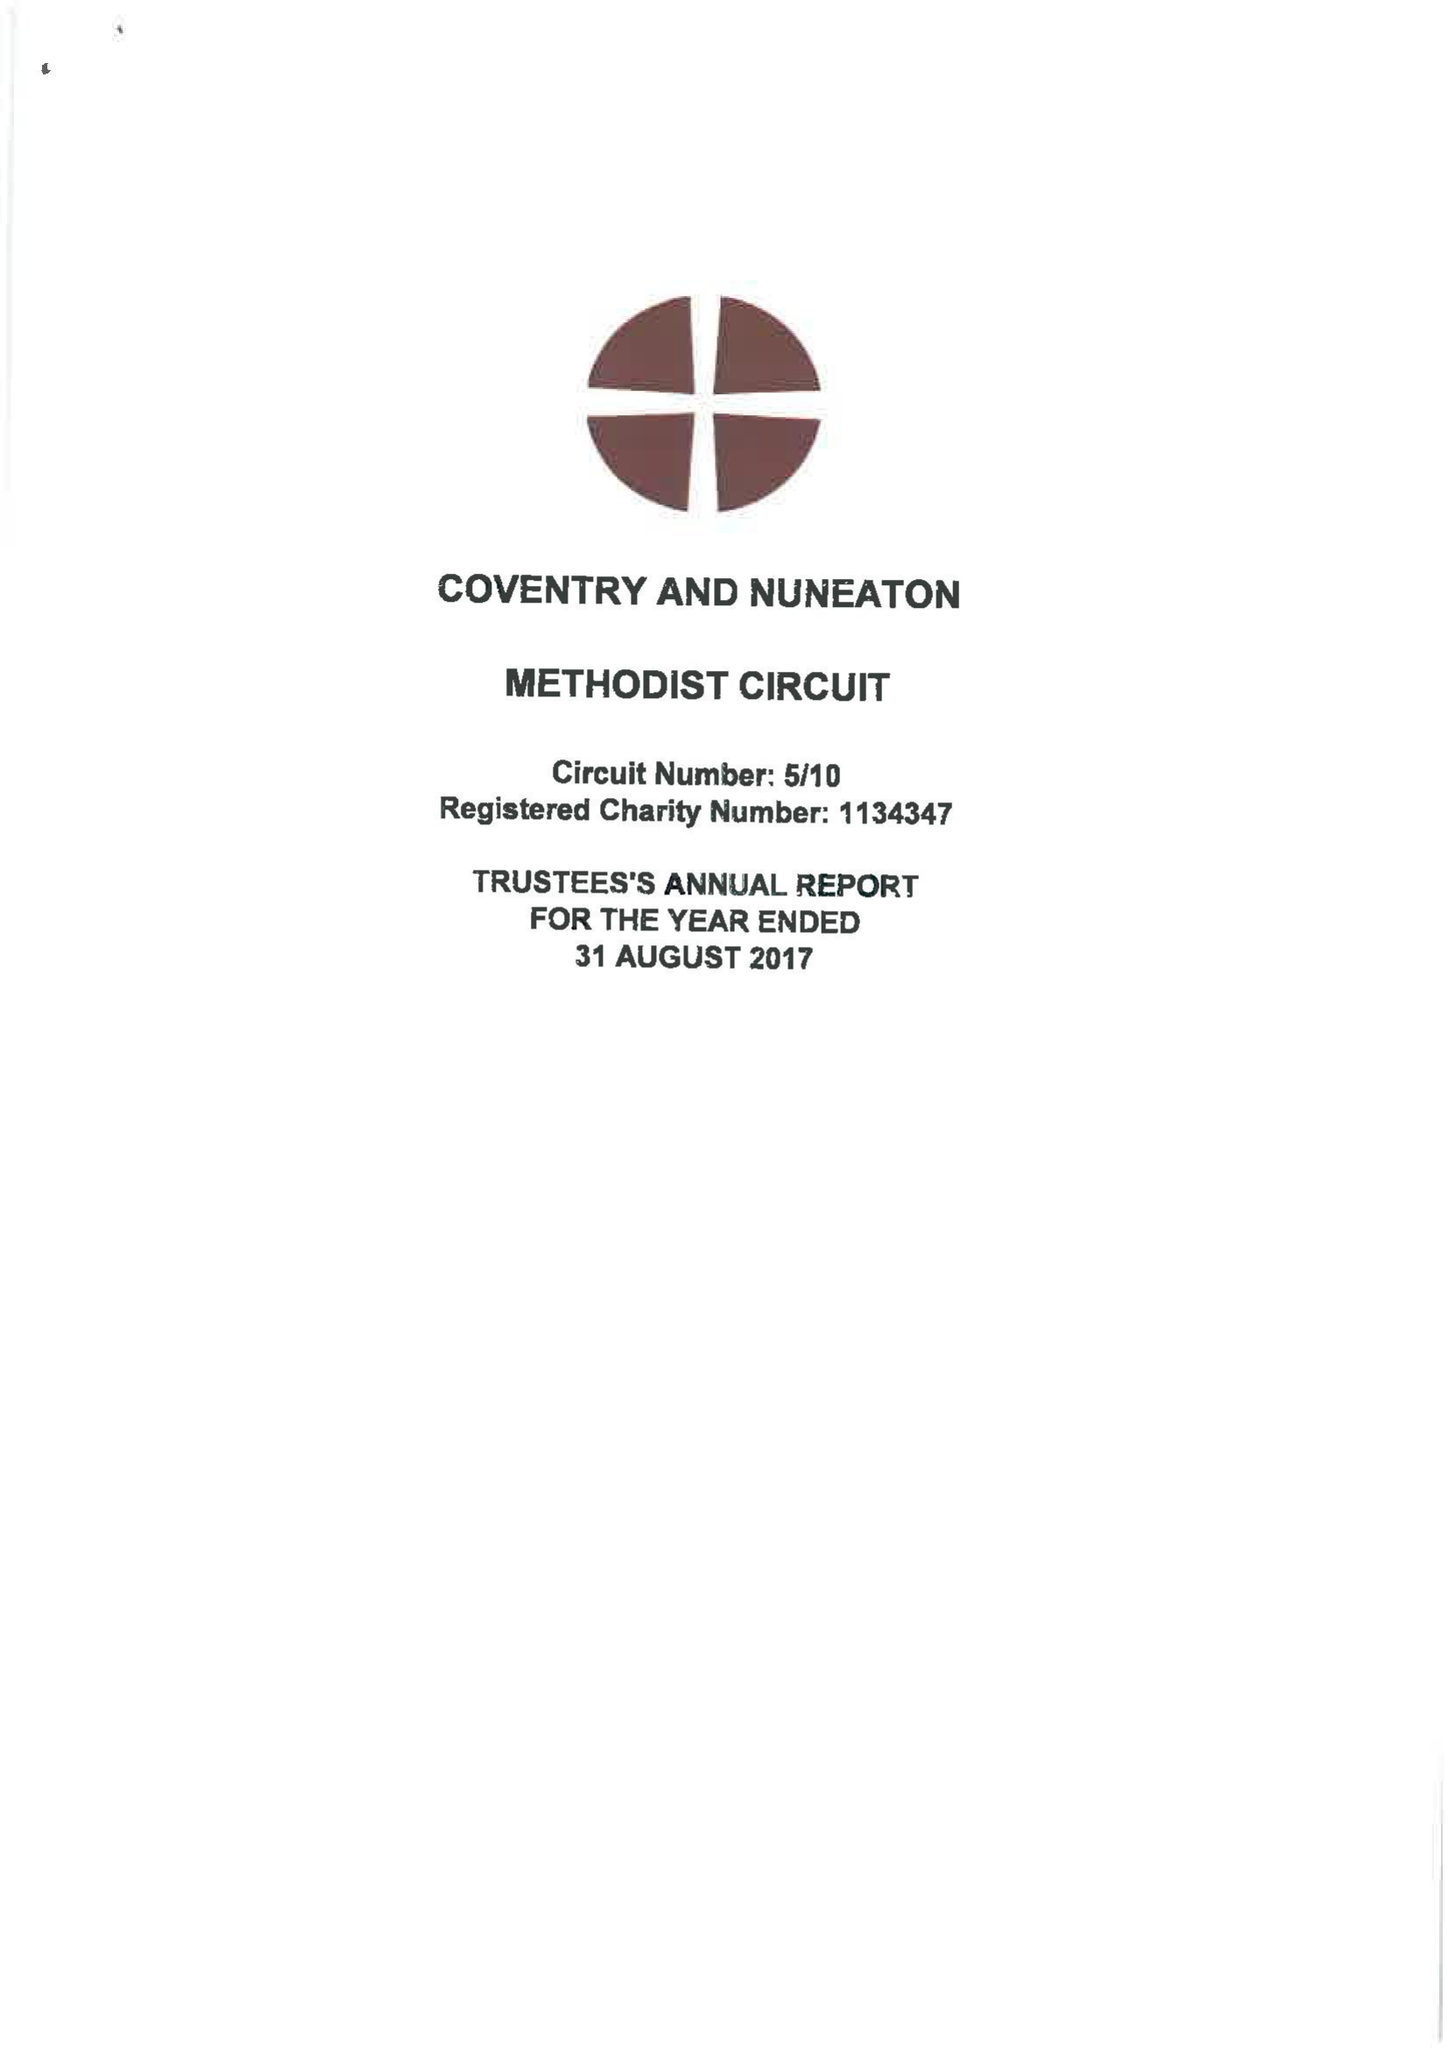What is the value for the report_date?
Answer the question using a single word or phrase. 2017-08-31 